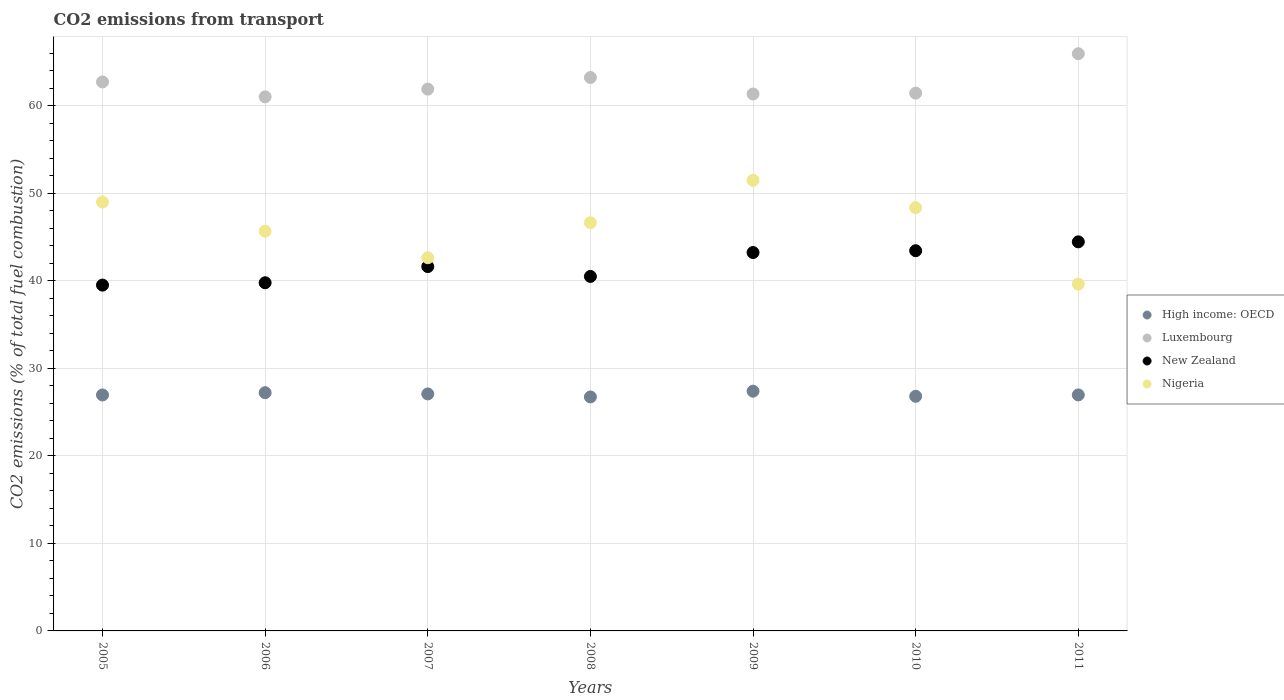Is the number of dotlines equal to the number of legend labels?
Your answer should be very brief. Yes. What is the total CO2 emitted in Nigeria in 2007?
Your answer should be very brief. 42.65. Across all years, what is the maximum total CO2 emitted in High income: OECD?
Your answer should be very brief. 27.4. Across all years, what is the minimum total CO2 emitted in Nigeria?
Offer a very short reply. 39.63. In which year was the total CO2 emitted in Nigeria minimum?
Your answer should be very brief. 2011. What is the total total CO2 emitted in Luxembourg in the graph?
Give a very brief answer. 437.73. What is the difference between the total CO2 emitted in High income: OECD in 2005 and that in 2011?
Your answer should be compact. -0.01. What is the difference between the total CO2 emitted in Nigeria in 2006 and the total CO2 emitted in Luxembourg in 2011?
Offer a very short reply. -20.28. What is the average total CO2 emitted in Luxembourg per year?
Give a very brief answer. 62.53. In the year 2010, what is the difference between the total CO2 emitted in Luxembourg and total CO2 emitted in New Zealand?
Offer a terse response. 18.01. What is the ratio of the total CO2 emitted in High income: OECD in 2007 to that in 2011?
Provide a short and direct response. 1. What is the difference between the highest and the second highest total CO2 emitted in Luxembourg?
Your answer should be very brief. 2.72. What is the difference between the highest and the lowest total CO2 emitted in Nigeria?
Ensure brevity in your answer.  11.86. How many dotlines are there?
Offer a very short reply. 4. How many years are there in the graph?
Provide a succinct answer. 7. What is the difference between two consecutive major ticks on the Y-axis?
Provide a short and direct response. 10. Are the values on the major ticks of Y-axis written in scientific E-notation?
Your answer should be very brief. No. Does the graph contain grids?
Your answer should be very brief. Yes. How many legend labels are there?
Provide a short and direct response. 4. What is the title of the graph?
Give a very brief answer. CO2 emissions from transport. Does "Oman" appear as one of the legend labels in the graph?
Give a very brief answer. No. What is the label or title of the Y-axis?
Provide a short and direct response. CO2 emissions (% of total fuel combustion). What is the CO2 emissions (% of total fuel combustion) in High income: OECD in 2005?
Give a very brief answer. 26.97. What is the CO2 emissions (% of total fuel combustion) of Luxembourg in 2005?
Offer a terse response. 62.74. What is the CO2 emissions (% of total fuel combustion) in New Zealand in 2005?
Provide a succinct answer. 39.52. What is the CO2 emissions (% of total fuel combustion) of Nigeria in 2005?
Your answer should be very brief. 49.01. What is the CO2 emissions (% of total fuel combustion) in High income: OECD in 2006?
Offer a very short reply. 27.23. What is the CO2 emissions (% of total fuel combustion) of Luxembourg in 2006?
Your answer should be very brief. 61.04. What is the CO2 emissions (% of total fuel combustion) of New Zealand in 2006?
Your answer should be very brief. 39.79. What is the CO2 emissions (% of total fuel combustion) of Nigeria in 2006?
Offer a very short reply. 45.68. What is the CO2 emissions (% of total fuel combustion) of High income: OECD in 2007?
Ensure brevity in your answer.  27.08. What is the CO2 emissions (% of total fuel combustion) of Luxembourg in 2007?
Your answer should be compact. 61.92. What is the CO2 emissions (% of total fuel combustion) of New Zealand in 2007?
Offer a terse response. 41.64. What is the CO2 emissions (% of total fuel combustion) of Nigeria in 2007?
Your response must be concise. 42.65. What is the CO2 emissions (% of total fuel combustion) in High income: OECD in 2008?
Your answer should be compact. 26.74. What is the CO2 emissions (% of total fuel combustion) in Luxembourg in 2008?
Your response must be concise. 63.25. What is the CO2 emissions (% of total fuel combustion) of New Zealand in 2008?
Make the answer very short. 40.51. What is the CO2 emissions (% of total fuel combustion) in Nigeria in 2008?
Provide a short and direct response. 46.65. What is the CO2 emissions (% of total fuel combustion) in High income: OECD in 2009?
Your answer should be very brief. 27.4. What is the CO2 emissions (% of total fuel combustion) of Luxembourg in 2009?
Provide a succinct answer. 61.36. What is the CO2 emissions (% of total fuel combustion) of New Zealand in 2009?
Offer a very short reply. 43.25. What is the CO2 emissions (% of total fuel combustion) in Nigeria in 2009?
Provide a succinct answer. 51.49. What is the CO2 emissions (% of total fuel combustion) of High income: OECD in 2010?
Make the answer very short. 26.82. What is the CO2 emissions (% of total fuel combustion) in Luxembourg in 2010?
Provide a short and direct response. 61.46. What is the CO2 emissions (% of total fuel combustion) of New Zealand in 2010?
Make the answer very short. 43.45. What is the CO2 emissions (% of total fuel combustion) of Nigeria in 2010?
Ensure brevity in your answer.  48.37. What is the CO2 emissions (% of total fuel combustion) in High income: OECD in 2011?
Your response must be concise. 26.97. What is the CO2 emissions (% of total fuel combustion) of Luxembourg in 2011?
Your response must be concise. 65.96. What is the CO2 emissions (% of total fuel combustion) of New Zealand in 2011?
Your answer should be very brief. 44.47. What is the CO2 emissions (% of total fuel combustion) of Nigeria in 2011?
Make the answer very short. 39.63. Across all years, what is the maximum CO2 emissions (% of total fuel combustion) in High income: OECD?
Give a very brief answer. 27.4. Across all years, what is the maximum CO2 emissions (% of total fuel combustion) in Luxembourg?
Your answer should be very brief. 65.96. Across all years, what is the maximum CO2 emissions (% of total fuel combustion) in New Zealand?
Your answer should be compact. 44.47. Across all years, what is the maximum CO2 emissions (% of total fuel combustion) of Nigeria?
Make the answer very short. 51.49. Across all years, what is the minimum CO2 emissions (% of total fuel combustion) in High income: OECD?
Your response must be concise. 26.74. Across all years, what is the minimum CO2 emissions (% of total fuel combustion) in Luxembourg?
Make the answer very short. 61.04. Across all years, what is the minimum CO2 emissions (% of total fuel combustion) of New Zealand?
Keep it short and to the point. 39.52. Across all years, what is the minimum CO2 emissions (% of total fuel combustion) of Nigeria?
Your answer should be very brief. 39.63. What is the total CO2 emissions (% of total fuel combustion) of High income: OECD in the graph?
Your response must be concise. 189.21. What is the total CO2 emissions (% of total fuel combustion) in Luxembourg in the graph?
Ensure brevity in your answer.  437.73. What is the total CO2 emissions (% of total fuel combustion) of New Zealand in the graph?
Ensure brevity in your answer.  292.63. What is the total CO2 emissions (% of total fuel combustion) of Nigeria in the graph?
Provide a short and direct response. 323.49. What is the difference between the CO2 emissions (% of total fuel combustion) of High income: OECD in 2005 and that in 2006?
Give a very brief answer. -0.26. What is the difference between the CO2 emissions (% of total fuel combustion) in Luxembourg in 2005 and that in 2006?
Your answer should be compact. 1.71. What is the difference between the CO2 emissions (% of total fuel combustion) of New Zealand in 2005 and that in 2006?
Make the answer very short. -0.27. What is the difference between the CO2 emissions (% of total fuel combustion) in Nigeria in 2005 and that in 2006?
Provide a short and direct response. 3.33. What is the difference between the CO2 emissions (% of total fuel combustion) of High income: OECD in 2005 and that in 2007?
Provide a succinct answer. -0.12. What is the difference between the CO2 emissions (% of total fuel combustion) of Luxembourg in 2005 and that in 2007?
Your answer should be very brief. 0.82. What is the difference between the CO2 emissions (% of total fuel combustion) of New Zealand in 2005 and that in 2007?
Your answer should be very brief. -2.12. What is the difference between the CO2 emissions (% of total fuel combustion) of Nigeria in 2005 and that in 2007?
Your response must be concise. 6.36. What is the difference between the CO2 emissions (% of total fuel combustion) in High income: OECD in 2005 and that in 2008?
Make the answer very short. 0.23. What is the difference between the CO2 emissions (% of total fuel combustion) in Luxembourg in 2005 and that in 2008?
Give a very brief answer. -0.51. What is the difference between the CO2 emissions (% of total fuel combustion) of New Zealand in 2005 and that in 2008?
Provide a succinct answer. -0.99. What is the difference between the CO2 emissions (% of total fuel combustion) of Nigeria in 2005 and that in 2008?
Ensure brevity in your answer.  2.36. What is the difference between the CO2 emissions (% of total fuel combustion) in High income: OECD in 2005 and that in 2009?
Make the answer very short. -0.43. What is the difference between the CO2 emissions (% of total fuel combustion) in Luxembourg in 2005 and that in 2009?
Provide a succinct answer. 1.38. What is the difference between the CO2 emissions (% of total fuel combustion) of New Zealand in 2005 and that in 2009?
Ensure brevity in your answer.  -3.72. What is the difference between the CO2 emissions (% of total fuel combustion) in Nigeria in 2005 and that in 2009?
Your answer should be very brief. -2.48. What is the difference between the CO2 emissions (% of total fuel combustion) of High income: OECD in 2005 and that in 2010?
Offer a very short reply. 0.15. What is the difference between the CO2 emissions (% of total fuel combustion) in Luxembourg in 2005 and that in 2010?
Your response must be concise. 1.28. What is the difference between the CO2 emissions (% of total fuel combustion) of New Zealand in 2005 and that in 2010?
Your response must be concise. -3.93. What is the difference between the CO2 emissions (% of total fuel combustion) of Nigeria in 2005 and that in 2010?
Offer a very short reply. 0.65. What is the difference between the CO2 emissions (% of total fuel combustion) in High income: OECD in 2005 and that in 2011?
Your answer should be compact. -0.01. What is the difference between the CO2 emissions (% of total fuel combustion) in Luxembourg in 2005 and that in 2011?
Provide a short and direct response. -3.22. What is the difference between the CO2 emissions (% of total fuel combustion) of New Zealand in 2005 and that in 2011?
Your answer should be very brief. -4.94. What is the difference between the CO2 emissions (% of total fuel combustion) in Nigeria in 2005 and that in 2011?
Keep it short and to the point. 9.38. What is the difference between the CO2 emissions (% of total fuel combustion) in High income: OECD in 2006 and that in 2007?
Make the answer very short. 0.15. What is the difference between the CO2 emissions (% of total fuel combustion) in Luxembourg in 2006 and that in 2007?
Your answer should be compact. -0.89. What is the difference between the CO2 emissions (% of total fuel combustion) in New Zealand in 2006 and that in 2007?
Your answer should be compact. -1.85. What is the difference between the CO2 emissions (% of total fuel combustion) of Nigeria in 2006 and that in 2007?
Offer a very short reply. 3.03. What is the difference between the CO2 emissions (% of total fuel combustion) in High income: OECD in 2006 and that in 2008?
Provide a succinct answer. 0.49. What is the difference between the CO2 emissions (% of total fuel combustion) of Luxembourg in 2006 and that in 2008?
Provide a short and direct response. -2.21. What is the difference between the CO2 emissions (% of total fuel combustion) of New Zealand in 2006 and that in 2008?
Your answer should be compact. -0.72. What is the difference between the CO2 emissions (% of total fuel combustion) of Nigeria in 2006 and that in 2008?
Make the answer very short. -0.97. What is the difference between the CO2 emissions (% of total fuel combustion) in High income: OECD in 2006 and that in 2009?
Offer a terse response. -0.17. What is the difference between the CO2 emissions (% of total fuel combustion) in Luxembourg in 2006 and that in 2009?
Offer a very short reply. -0.32. What is the difference between the CO2 emissions (% of total fuel combustion) of New Zealand in 2006 and that in 2009?
Your answer should be very brief. -3.46. What is the difference between the CO2 emissions (% of total fuel combustion) in Nigeria in 2006 and that in 2009?
Ensure brevity in your answer.  -5.81. What is the difference between the CO2 emissions (% of total fuel combustion) of High income: OECD in 2006 and that in 2010?
Make the answer very short. 0.41. What is the difference between the CO2 emissions (% of total fuel combustion) of Luxembourg in 2006 and that in 2010?
Ensure brevity in your answer.  -0.42. What is the difference between the CO2 emissions (% of total fuel combustion) of New Zealand in 2006 and that in 2010?
Ensure brevity in your answer.  -3.66. What is the difference between the CO2 emissions (% of total fuel combustion) in Nigeria in 2006 and that in 2010?
Offer a very short reply. -2.69. What is the difference between the CO2 emissions (% of total fuel combustion) in High income: OECD in 2006 and that in 2011?
Provide a succinct answer. 0.26. What is the difference between the CO2 emissions (% of total fuel combustion) of Luxembourg in 2006 and that in 2011?
Provide a succinct answer. -4.93. What is the difference between the CO2 emissions (% of total fuel combustion) of New Zealand in 2006 and that in 2011?
Make the answer very short. -4.68. What is the difference between the CO2 emissions (% of total fuel combustion) in Nigeria in 2006 and that in 2011?
Your answer should be compact. 6.05. What is the difference between the CO2 emissions (% of total fuel combustion) in High income: OECD in 2007 and that in 2008?
Offer a terse response. 0.34. What is the difference between the CO2 emissions (% of total fuel combustion) of Luxembourg in 2007 and that in 2008?
Provide a short and direct response. -1.33. What is the difference between the CO2 emissions (% of total fuel combustion) in New Zealand in 2007 and that in 2008?
Offer a terse response. 1.13. What is the difference between the CO2 emissions (% of total fuel combustion) of Nigeria in 2007 and that in 2008?
Your answer should be compact. -4. What is the difference between the CO2 emissions (% of total fuel combustion) in High income: OECD in 2007 and that in 2009?
Give a very brief answer. -0.32. What is the difference between the CO2 emissions (% of total fuel combustion) in Luxembourg in 2007 and that in 2009?
Offer a terse response. 0.56. What is the difference between the CO2 emissions (% of total fuel combustion) in New Zealand in 2007 and that in 2009?
Provide a succinct answer. -1.61. What is the difference between the CO2 emissions (% of total fuel combustion) of Nigeria in 2007 and that in 2009?
Make the answer very short. -8.84. What is the difference between the CO2 emissions (% of total fuel combustion) of High income: OECD in 2007 and that in 2010?
Keep it short and to the point. 0.27. What is the difference between the CO2 emissions (% of total fuel combustion) of Luxembourg in 2007 and that in 2010?
Offer a very short reply. 0.46. What is the difference between the CO2 emissions (% of total fuel combustion) in New Zealand in 2007 and that in 2010?
Ensure brevity in your answer.  -1.81. What is the difference between the CO2 emissions (% of total fuel combustion) of Nigeria in 2007 and that in 2010?
Your answer should be compact. -5.72. What is the difference between the CO2 emissions (% of total fuel combustion) of High income: OECD in 2007 and that in 2011?
Offer a terse response. 0.11. What is the difference between the CO2 emissions (% of total fuel combustion) of Luxembourg in 2007 and that in 2011?
Your answer should be very brief. -4.04. What is the difference between the CO2 emissions (% of total fuel combustion) of New Zealand in 2007 and that in 2011?
Make the answer very short. -2.83. What is the difference between the CO2 emissions (% of total fuel combustion) in Nigeria in 2007 and that in 2011?
Offer a very short reply. 3.02. What is the difference between the CO2 emissions (% of total fuel combustion) in High income: OECD in 2008 and that in 2009?
Your answer should be compact. -0.66. What is the difference between the CO2 emissions (% of total fuel combustion) in Luxembourg in 2008 and that in 2009?
Provide a short and direct response. 1.89. What is the difference between the CO2 emissions (% of total fuel combustion) in New Zealand in 2008 and that in 2009?
Give a very brief answer. -2.73. What is the difference between the CO2 emissions (% of total fuel combustion) in Nigeria in 2008 and that in 2009?
Make the answer very short. -4.84. What is the difference between the CO2 emissions (% of total fuel combustion) of High income: OECD in 2008 and that in 2010?
Offer a very short reply. -0.08. What is the difference between the CO2 emissions (% of total fuel combustion) of Luxembourg in 2008 and that in 2010?
Give a very brief answer. 1.79. What is the difference between the CO2 emissions (% of total fuel combustion) in New Zealand in 2008 and that in 2010?
Give a very brief answer. -2.94. What is the difference between the CO2 emissions (% of total fuel combustion) in Nigeria in 2008 and that in 2010?
Keep it short and to the point. -1.72. What is the difference between the CO2 emissions (% of total fuel combustion) in High income: OECD in 2008 and that in 2011?
Keep it short and to the point. -0.23. What is the difference between the CO2 emissions (% of total fuel combustion) of Luxembourg in 2008 and that in 2011?
Keep it short and to the point. -2.72. What is the difference between the CO2 emissions (% of total fuel combustion) in New Zealand in 2008 and that in 2011?
Offer a very short reply. -3.95. What is the difference between the CO2 emissions (% of total fuel combustion) of Nigeria in 2008 and that in 2011?
Make the answer very short. 7.02. What is the difference between the CO2 emissions (% of total fuel combustion) in High income: OECD in 2009 and that in 2010?
Ensure brevity in your answer.  0.58. What is the difference between the CO2 emissions (% of total fuel combustion) of Luxembourg in 2009 and that in 2010?
Offer a very short reply. -0.1. What is the difference between the CO2 emissions (% of total fuel combustion) in New Zealand in 2009 and that in 2010?
Offer a terse response. -0.2. What is the difference between the CO2 emissions (% of total fuel combustion) in Nigeria in 2009 and that in 2010?
Give a very brief answer. 3.13. What is the difference between the CO2 emissions (% of total fuel combustion) of High income: OECD in 2009 and that in 2011?
Offer a terse response. 0.43. What is the difference between the CO2 emissions (% of total fuel combustion) in Luxembourg in 2009 and that in 2011?
Your response must be concise. -4.6. What is the difference between the CO2 emissions (% of total fuel combustion) in New Zealand in 2009 and that in 2011?
Keep it short and to the point. -1.22. What is the difference between the CO2 emissions (% of total fuel combustion) in Nigeria in 2009 and that in 2011?
Offer a very short reply. 11.86. What is the difference between the CO2 emissions (% of total fuel combustion) in High income: OECD in 2010 and that in 2011?
Offer a very short reply. -0.16. What is the difference between the CO2 emissions (% of total fuel combustion) of Luxembourg in 2010 and that in 2011?
Provide a succinct answer. -4.51. What is the difference between the CO2 emissions (% of total fuel combustion) of New Zealand in 2010 and that in 2011?
Give a very brief answer. -1.01. What is the difference between the CO2 emissions (% of total fuel combustion) in Nigeria in 2010 and that in 2011?
Your answer should be very brief. 8.74. What is the difference between the CO2 emissions (% of total fuel combustion) in High income: OECD in 2005 and the CO2 emissions (% of total fuel combustion) in Luxembourg in 2006?
Provide a short and direct response. -34.07. What is the difference between the CO2 emissions (% of total fuel combustion) in High income: OECD in 2005 and the CO2 emissions (% of total fuel combustion) in New Zealand in 2006?
Keep it short and to the point. -12.82. What is the difference between the CO2 emissions (% of total fuel combustion) of High income: OECD in 2005 and the CO2 emissions (% of total fuel combustion) of Nigeria in 2006?
Your answer should be compact. -18.71. What is the difference between the CO2 emissions (% of total fuel combustion) of Luxembourg in 2005 and the CO2 emissions (% of total fuel combustion) of New Zealand in 2006?
Make the answer very short. 22.95. What is the difference between the CO2 emissions (% of total fuel combustion) of Luxembourg in 2005 and the CO2 emissions (% of total fuel combustion) of Nigeria in 2006?
Offer a terse response. 17.06. What is the difference between the CO2 emissions (% of total fuel combustion) of New Zealand in 2005 and the CO2 emissions (% of total fuel combustion) of Nigeria in 2006?
Offer a very short reply. -6.16. What is the difference between the CO2 emissions (% of total fuel combustion) of High income: OECD in 2005 and the CO2 emissions (% of total fuel combustion) of Luxembourg in 2007?
Your answer should be compact. -34.96. What is the difference between the CO2 emissions (% of total fuel combustion) in High income: OECD in 2005 and the CO2 emissions (% of total fuel combustion) in New Zealand in 2007?
Provide a short and direct response. -14.67. What is the difference between the CO2 emissions (% of total fuel combustion) in High income: OECD in 2005 and the CO2 emissions (% of total fuel combustion) in Nigeria in 2007?
Make the answer very short. -15.68. What is the difference between the CO2 emissions (% of total fuel combustion) in Luxembourg in 2005 and the CO2 emissions (% of total fuel combustion) in New Zealand in 2007?
Keep it short and to the point. 21.1. What is the difference between the CO2 emissions (% of total fuel combustion) in Luxembourg in 2005 and the CO2 emissions (% of total fuel combustion) in Nigeria in 2007?
Offer a very short reply. 20.09. What is the difference between the CO2 emissions (% of total fuel combustion) of New Zealand in 2005 and the CO2 emissions (% of total fuel combustion) of Nigeria in 2007?
Ensure brevity in your answer.  -3.13. What is the difference between the CO2 emissions (% of total fuel combustion) of High income: OECD in 2005 and the CO2 emissions (% of total fuel combustion) of Luxembourg in 2008?
Provide a succinct answer. -36.28. What is the difference between the CO2 emissions (% of total fuel combustion) in High income: OECD in 2005 and the CO2 emissions (% of total fuel combustion) in New Zealand in 2008?
Provide a succinct answer. -13.55. What is the difference between the CO2 emissions (% of total fuel combustion) in High income: OECD in 2005 and the CO2 emissions (% of total fuel combustion) in Nigeria in 2008?
Your answer should be very brief. -19.69. What is the difference between the CO2 emissions (% of total fuel combustion) in Luxembourg in 2005 and the CO2 emissions (% of total fuel combustion) in New Zealand in 2008?
Make the answer very short. 22.23. What is the difference between the CO2 emissions (% of total fuel combustion) of Luxembourg in 2005 and the CO2 emissions (% of total fuel combustion) of Nigeria in 2008?
Your response must be concise. 16.09. What is the difference between the CO2 emissions (% of total fuel combustion) of New Zealand in 2005 and the CO2 emissions (% of total fuel combustion) of Nigeria in 2008?
Ensure brevity in your answer.  -7.13. What is the difference between the CO2 emissions (% of total fuel combustion) of High income: OECD in 2005 and the CO2 emissions (% of total fuel combustion) of Luxembourg in 2009?
Your response must be concise. -34.39. What is the difference between the CO2 emissions (% of total fuel combustion) in High income: OECD in 2005 and the CO2 emissions (% of total fuel combustion) in New Zealand in 2009?
Your response must be concise. -16.28. What is the difference between the CO2 emissions (% of total fuel combustion) of High income: OECD in 2005 and the CO2 emissions (% of total fuel combustion) of Nigeria in 2009?
Keep it short and to the point. -24.53. What is the difference between the CO2 emissions (% of total fuel combustion) in Luxembourg in 2005 and the CO2 emissions (% of total fuel combustion) in New Zealand in 2009?
Offer a terse response. 19.49. What is the difference between the CO2 emissions (% of total fuel combustion) of Luxembourg in 2005 and the CO2 emissions (% of total fuel combustion) of Nigeria in 2009?
Provide a short and direct response. 11.25. What is the difference between the CO2 emissions (% of total fuel combustion) in New Zealand in 2005 and the CO2 emissions (% of total fuel combustion) in Nigeria in 2009?
Your response must be concise. -11.97. What is the difference between the CO2 emissions (% of total fuel combustion) in High income: OECD in 2005 and the CO2 emissions (% of total fuel combustion) in Luxembourg in 2010?
Offer a very short reply. -34.49. What is the difference between the CO2 emissions (% of total fuel combustion) in High income: OECD in 2005 and the CO2 emissions (% of total fuel combustion) in New Zealand in 2010?
Keep it short and to the point. -16.48. What is the difference between the CO2 emissions (% of total fuel combustion) in High income: OECD in 2005 and the CO2 emissions (% of total fuel combustion) in Nigeria in 2010?
Ensure brevity in your answer.  -21.4. What is the difference between the CO2 emissions (% of total fuel combustion) in Luxembourg in 2005 and the CO2 emissions (% of total fuel combustion) in New Zealand in 2010?
Provide a succinct answer. 19.29. What is the difference between the CO2 emissions (% of total fuel combustion) of Luxembourg in 2005 and the CO2 emissions (% of total fuel combustion) of Nigeria in 2010?
Make the answer very short. 14.37. What is the difference between the CO2 emissions (% of total fuel combustion) in New Zealand in 2005 and the CO2 emissions (% of total fuel combustion) in Nigeria in 2010?
Offer a terse response. -8.85. What is the difference between the CO2 emissions (% of total fuel combustion) in High income: OECD in 2005 and the CO2 emissions (% of total fuel combustion) in Luxembourg in 2011?
Offer a terse response. -39. What is the difference between the CO2 emissions (% of total fuel combustion) in High income: OECD in 2005 and the CO2 emissions (% of total fuel combustion) in New Zealand in 2011?
Your answer should be compact. -17.5. What is the difference between the CO2 emissions (% of total fuel combustion) in High income: OECD in 2005 and the CO2 emissions (% of total fuel combustion) in Nigeria in 2011?
Keep it short and to the point. -12.66. What is the difference between the CO2 emissions (% of total fuel combustion) in Luxembourg in 2005 and the CO2 emissions (% of total fuel combustion) in New Zealand in 2011?
Give a very brief answer. 18.28. What is the difference between the CO2 emissions (% of total fuel combustion) of Luxembourg in 2005 and the CO2 emissions (% of total fuel combustion) of Nigeria in 2011?
Provide a succinct answer. 23.11. What is the difference between the CO2 emissions (% of total fuel combustion) of New Zealand in 2005 and the CO2 emissions (% of total fuel combustion) of Nigeria in 2011?
Offer a very short reply. -0.11. What is the difference between the CO2 emissions (% of total fuel combustion) of High income: OECD in 2006 and the CO2 emissions (% of total fuel combustion) of Luxembourg in 2007?
Your answer should be very brief. -34.69. What is the difference between the CO2 emissions (% of total fuel combustion) in High income: OECD in 2006 and the CO2 emissions (% of total fuel combustion) in New Zealand in 2007?
Your response must be concise. -14.41. What is the difference between the CO2 emissions (% of total fuel combustion) in High income: OECD in 2006 and the CO2 emissions (% of total fuel combustion) in Nigeria in 2007?
Give a very brief answer. -15.42. What is the difference between the CO2 emissions (% of total fuel combustion) of Luxembourg in 2006 and the CO2 emissions (% of total fuel combustion) of New Zealand in 2007?
Your answer should be very brief. 19.4. What is the difference between the CO2 emissions (% of total fuel combustion) in Luxembourg in 2006 and the CO2 emissions (% of total fuel combustion) in Nigeria in 2007?
Provide a short and direct response. 18.39. What is the difference between the CO2 emissions (% of total fuel combustion) of New Zealand in 2006 and the CO2 emissions (% of total fuel combustion) of Nigeria in 2007?
Give a very brief answer. -2.86. What is the difference between the CO2 emissions (% of total fuel combustion) of High income: OECD in 2006 and the CO2 emissions (% of total fuel combustion) of Luxembourg in 2008?
Provide a short and direct response. -36.02. What is the difference between the CO2 emissions (% of total fuel combustion) in High income: OECD in 2006 and the CO2 emissions (% of total fuel combustion) in New Zealand in 2008?
Give a very brief answer. -13.28. What is the difference between the CO2 emissions (% of total fuel combustion) in High income: OECD in 2006 and the CO2 emissions (% of total fuel combustion) in Nigeria in 2008?
Ensure brevity in your answer.  -19.42. What is the difference between the CO2 emissions (% of total fuel combustion) in Luxembourg in 2006 and the CO2 emissions (% of total fuel combustion) in New Zealand in 2008?
Provide a short and direct response. 20.52. What is the difference between the CO2 emissions (% of total fuel combustion) in Luxembourg in 2006 and the CO2 emissions (% of total fuel combustion) in Nigeria in 2008?
Your answer should be very brief. 14.38. What is the difference between the CO2 emissions (% of total fuel combustion) of New Zealand in 2006 and the CO2 emissions (% of total fuel combustion) of Nigeria in 2008?
Your response must be concise. -6.86. What is the difference between the CO2 emissions (% of total fuel combustion) in High income: OECD in 2006 and the CO2 emissions (% of total fuel combustion) in Luxembourg in 2009?
Make the answer very short. -34.13. What is the difference between the CO2 emissions (% of total fuel combustion) in High income: OECD in 2006 and the CO2 emissions (% of total fuel combustion) in New Zealand in 2009?
Make the answer very short. -16.02. What is the difference between the CO2 emissions (% of total fuel combustion) of High income: OECD in 2006 and the CO2 emissions (% of total fuel combustion) of Nigeria in 2009?
Provide a short and direct response. -24.26. What is the difference between the CO2 emissions (% of total fuel combustion) of Luxembourg in 2006 and the CO2 emissions (% of total fuel combustion) of New Zealand in 2009?
Provide a succinct answer. 17.79. What is the difference between the CO2 emissions (% of total fuel combustion) in Luxembourg in 2006 and the CO2 emissions (% of total fuel combustion) in Nigeria in 2009?
Provide a succinct answer. 9.54. What is the difference between the CO2 emissions (% of total fuel combustion) of New Zealand in 2006 and the CO2 emissions (% of total fuel combustion) of Nigeria in 2009?
Offer a very short reply. -11.71. What is the difference between the CO2 emissions (% of total fuel combustion) in High income: OECD in 2006 and the CO2 emissions (% of total fuel combustion) in Luxembourg in 2010?
Offer a terse response. -34.23. What is the difference between the CO2 emissions (% of total fuel combustion) of High income: OECD in 2006 and the CO2 emissions (% of total fuel combustion) of New Zealand in 2010?
Give a very brief answer. -16.22. What is the difference between the CO2 emissions (% of total fuel combustion) of High income: OECD in 2006 and the CO2 emissions (% of total fuel combustion) of Nigeria in 2010?
Your answer should be very brief. -21.14. What is the difference between the CO2 emissions (% of total fuel combustion) of Luxembourg in 2006 and the CO2 emissions (% of total fuel combustion) of New Zealand in 2010?
Your answer should be very brief. 17.59. What is the difference between the CO2 emissions (% of total fuel combustion) of Luxembourg in 2006 and the CO2 emissions (% of total fuel combustion) of Nigeria in 2010?
Your answer should be compact. 12.67. What is the difference between the CO2 emissions (% of total fuel combustion) in New Zealand in 2006 and the CO2 emissions (% of total fuel combustion) in Nigeria in 2010?
Make the answer very short. -8.58. What is the difference between the CO2 emissions (% of total fuel combustion) in High income: OECD in 2006 and the CO2 emissions (% of total fuel combustion) in Luxembourg in 2011?
Your response must be concise. -38.73. What is the difference between the CO2 emissions (% of total fuel combustion) of High income: OECD in 2006 and the CO2 emissions (% of total fuel combustion) of New Zealand in 2011?
Make the answer very short. -17.24. What is the difference between the CO2 emissions (% of total fuel combustion) of High income: OECD in 2006 and the CO2 emissions (% of total fuel combustion) of Nigeria in 2011?
Offer a terse response. -12.4. What is the difference between the CO2 emissions (% of total fuel combustion) of Luxembourg in 2006 and the CO2 emissions (% of total fuel combustion) of New Zealand in 2011?
Offer a terse response. 16.57. What is the difference between the CO2 emissions (% of total fuel combustion) of Luxembourg in 2006 and the CO2 emissions (% of total fuel combustion) of Nigeria in 2011?
Provide a short and direct response. 21.41. What is the difference between the CO2 emissions (% of total fuel combustion) of New Zealand in 2006 and the CO2 emissions (% of total fuel combustion) of Nigeria in 2011?
Give a very brief answer. 0.16. What is the difference between the CO2 emissions (% of total fuel combustion) in High income: OECD in 2007 and the CO2 emissions (% of total fuel combustion) in Luxembourg in 2008?
Make the answer very short. -36.16. What is the difference between the CO2 emissions (% of total fuel combustion) of High income: OECD in 2007 and the CO2 emissions (% of total fuel combustion) of New Zealand in 2008?
Offer a very short reply. -13.43. What is the difference between the CO2 emissions (% of total fuel combustion) in High income: OECD in 2007 and the CO2 emissions (% of total fuel combustion) in Nigeria in 2008?
Your answer should be compact. -19.57. What is the difference between the CO2 emissions (% of total fuel combustion) in Luxembourg in 2007 and the CO2 emissions (% of total fuel combustion) in New Zealand in 2008?
Provide a short and direct response. 21.41. What is the difference between the CO2 emissions (% of total fuel combustion) of Luxembourg in 2007 and the CO2 emissions (% of total fuel combustion) of Nigeria in 2008?
Your answer should be compact. 15.27. What is the difference between the CO2 emissions (% of total fuel combustion) of New Zealand in 2007 and the CO2 emissions (% of total fuel combustion) of Nigeria in 2008?
Your answer should be compact. -5.01. What is the difference between the CO2 emissions (% of total fuel combustion) in High income: OECD in 2007 and the CO2 emissions (% of total fuel combustion) in Luxembourg in 2009?
Keep it short and to the point. -34.28. What is the difference between the CO2 emissions (% of total fuel combustion) of High income: OECD in 2007 and the CO2 emissions (% of total fuel combustion) of New Zealand in 2009?
Your response must be concise. -16.16. What is the difference between the CO2 emissions (% of total fuel combustion) of High income: OECD in 2007 and the CO2 emissions (% of total fuel combustion) of Nigeria in 2009?
Your response must be concise. -24.41. What is the difference between the CO2 emissions (% of total fuel combustion) of Luxembourg in 2007 and the CO2 emissions (% of total fuel combustion) of New Zealand in 2009?
Offer a terse response. 18.68. What is the difference between the CO2 emissions (% of total fuel combustion) in Luxembourg in 2007 and the CO2 emissions (% of total fuel combustion) in Nigeria in 2009?
Provide a succinct answer. 10.43. What is the difference between the CO2 emissions (% of total fuel combustion) of New Zealand in 2007 and the CO2 emissions (% of total fuel combustion) of Nigeria in 2009?
Offer a terse response. -9.85. What is the difference between the CO2 emissions (% of total fuel combustion) of High income: OECD in 2007 and the CO2 emissions (% of total fuel combustion) of Luxembourg in 2010?
Your answer should be compact. -34.37. What is the difference between the CO2 emissions (% of total fuel combustion) in High income: OECD in 2007 and the CO2 emissions (% of total fuel combustion) in New Zealand in 2010?
Your response must be concise. -16.37. What is the difference between the CO2 emissions (% of total fuel combustion) of High income: OECD in 2007 and the CO2 emissions (% of total fuel combustion) of Nigeria in 2010?
Your answer should be very brief. -21.28. What is the difference between the CO2 emissions (% of total fuel combustion) in Luxembourg in 2007 and the CO2 emissions (% of total fuel combustion) in New Zealand in 2010?
Offer a very short reply. 18.47. What is the difference between the CO2 emissions (% of total fuel combustion) in Luxembourg in 2007 and the CO2 emissions (% of total fuel combustion) in Nigeria in 2010?
Ensure brevity in your answer.  13.55. What is the difference between the CO2 emissions (% of total fuel combustion) of New Zealand in 2007 and the CO2 emissions (% of total fuel combustion) of Nigeria in 2010?
Ensure brevity in your answer.  -6.73. What is the difference between the CO2 emissions (% of total fuel combustion) in High income: OECD in 2007 and the CO2 emissions (% of total fuel combustion) in Luxembourg in 2011?
Your answer should be compact. -38.88. What is the difference between the CO2 emissions (% of total fuel combustion) in High income: OECD in 2007 and the CO2 emissions (% of total fuel combustion) in New Zealand in 2011?
Your answer should be very brief. -17.38. What is the difference between the CO2 emissions (% of total fuel combustion) of High income: OECD in 2007 and the CO2 emissions (% of total fuel combustion) of Nigeria in 2011?
Keep it short and to the point. -12.55. What is the difference between the CO2 emissions (% of total fuel combustion) in Luxembourg in 2007 and the CO2 emissions (% of total fuel combustion) in New Zealand in 2011?
Your answer should be compact. 17.46. What is the difference between the CO2 emissions (% of total fuel combustion) in Luxembourg in 2007 and the CO2 emissions (% of total fuel combustion) in Nigeria in 2011?
Keep it short and to the point. 22.29. What is the difference between the CO2 emissions (% of total fuel combustion) in New Zealand in 2007 and the CO2 emissions (% of total fuel combustion) in Nigeria in 2011?
Ensure brevity in your answer.  2.01. What is the difference between the CO2 emissions (% of total fuel combustion) in High income: OECD in 2008 and the CO2 emissions (% of total fuel combustion) in Luxembourg in 2009?
Give a very brief answer. -34.62. What is the difference between the CO2 emissions (% of total fuel combustion) in High income: OECD in 2008 and the CO2 emissions (% of total fuel combustion) in New Zealand in 2009?
Offer a terse response. -16.51. What is the difference between the CO2 emissions (% of total fuel combustion) of High income: OECD in 2008 and the CO2 emissions (% of total fuel combustion) of Nigeria in 2009?
Your answer should be very brief. -24.75. What is the difference between the CO2 emissions (% of total fuel combustion) in Luxembourg in 2008 and the CO2 emissions (% of total fuel combustion) in New Zealand in 2009?
Your answer should be very brief. 20. What is the difference between the CO2 emissions (% of total fuel combustion) of Luxembourg in 2008 and the CO2 emissions (% of total fuel combustion) of Nigeria in 2009?
Your answer should be very brief. 11.75. What is the difference between the CO2 emissions (% of total fuel combustion) of New Zealand in 2008 and the CO2 emissions (% of total fuel combustion) of Nigeria in 2009?
Keep it short and to the point. -10.98. What is the difference between the CO2 emissions (% of total fuel combustion) of High income: OECD in 2008 and the CO2 emissions (% of total fuel combustion) of Luxembourg in 2010?
Your answer should be very brief. -34.72. What is the difference between the CO2 emissions (% of total fuel combustion) in High income: OECD in 2008 and the CO2 emissions (% of total fuel combustion) in New Zealand in 2010?
Give a very brief answer. -16.71. What is the difference between the CO2 emissions (% of total fuel combustion) in High income: OECD in 2008 and the CO2 emissions (% of total fuel combustion) in Nigeria in 2010?
Your answer should be very brief. -21.63. What is the difference between the CO2 emissions (% of total fuel combustion) of Luxembourg in 2008 and the CO2 emissions (% of total fuel combustion) of New Zealand in 2010?
Offer a terse response. 19.8. What is the difference between the CO2 emissions (% of total fuel combustion) of Luxembourg in 2008 and the CO2 emissions (% of total fuel combustion) of Nigeria in 2010?
Ensure brevity in your answer.  14.88. What is the difference between the CO2 emissions (% of total fuel combustion) in New Zealand in 2008 and the CO2 emissions (% of total fuel combustion) in Nigeria in 2010?
Provide a succinct answer. -7.86. What is the difference between the CO2 emissions (% of total fuel combustion) in High income: OECD in 2008 and the CO2 emissions (% of total fuel combustion) in Luxembourg in 2011?
Give a very brief answer. -39.22. What is the difference between the CO2 emissions (% of total fuel combustion) of High income: OECD in 2008 and the CO2 emissions (% of total fuel combustion) of New Zealand in 2011?
Make the answer very short. -17.73. What is the difference between the CO2 emissions (% of total fuel combustion) of High income: OECD in 2008 and the CO2 emissions (% of total fuel combustion) of Nigeria in 2011?
Offer a terse response. -12.89. What is the difference between the CO2 emissions (% of total fuel combustion) in Luxembourg in 2008 and the CO2 emissions (% of total fuel combustion) in New Zealand in 2011?
Your answer should be very brief. 18.78. What is the difference between the CO2 emissions (% of total fuel combustion) in Luxembourg in 2008 and the CO2 emissions (% of total fuel combustion) in Nigeria in 2011?
Keep it short and to the point. 23.62. What is the difference between the CO2 emissions (% of total fuel combustion) of New Zealand in 2008 and the CO2 emissions (% of total fuel combustion) of Nigeria in 2011?
Your answer should be compact. 0.88. What is the difference between the CO2 emissions (% of total fuel combustion) of High income: OECD in 2009 and the CO2 emissions (% of total fuel combustion) of Luxembourg in 2010?
Your answer should be compact. -34.06. What is the difference between the CO2 emissions (% of total fuel combustion) in High income: OECD in 2009 and the CO2 emissions (% of total fuel combustion) in New Zealand in 2010?
Provide a succinct answer. -16.05. What is the difference between the CO2 emissions (% of total fuel combustion) in High income: OECD in 2009 and the CO2 emissions (% of total fuel combustion) in Nigeria in 2010?
Provide a succinct answer. -20.97. What is the difference between the CO2 emissions (% of total fuel combustion) in Luxembourg in 2009 and the CO2 emissions (% of total fuel combustion) in New Zealand in 2010?
Provide a short and direct response. 17.91. What is the difference between the CO2 emissions (% of total fuel combustion) of Luxembourg in 2009 and the CO2 emissions (% of total fuel combustion) of Nigeria in 2010?
Keep it short and to the point. 12.99. What is the difference between the CO2 emissions (% of total fuel combustion) of New Zealand in 2009 and the CO2 emissions (% of total fuel combustion) of Nigeria in 2010?
Your response must be concise. -5.12. What is the difference between the CO2 emissions (% of total fuel combustion) of High income: OECD in 2009 and the CO2 emissions (% of total fuel combustion) of Luxembourg in 2011?
Give a very brief answer. -38.56. What is the difference between the CO2 emissions (% of total fuel combustion) of High income: OECD in 2009 and the CO2 emissions (% of total fuel combustion) of New Zealand in 2011?
Provide a succinct answer. -17.07. What is the difference between the CO2 emissions (% of total fuel combustion) in High income: OECD in 2009 and the CO2 emissions (% of total fuel combustion) in Nigeria in 2011?
Provide a succinct answer. -12.23. What is the difference between the CO2 emissions (% of total fuel combustion) of Luxembourg in 2009 and the CO2 emissions (% of total fuel combustion) of New Zealand in 2011?
Your answer should be very brief. 16.89. What is the difference between the CO2 emissions (% of total fuel combustion) of Luxembourg in 2009 and the CO2 emissions (% of total fuel combustion) of Nigeria in 2011?
Your answer should be compact. 21.73. What is the difference between the CO2 emissions (% of total fuel combustion) in New Zealand in 2009 and the CO2 emissions (% of total fuel combustion) in Nigeria in 2011?
Offer a terse response. 3.62. What is the difference between the CO2 emissions (% of total fuel combustion) of High income: OECD in 2010 and the CO2 emissions (% of total fuel combustion) of Luxembourg in 2011?
Your answer should be very brief. -39.15. What is the difference between the CO2 emissions (% of total fuel combustion) of High income: OECD in 2010 and the CO2 emissions (% of total fuel combustion) of New Zealand in 2011?
Your answer should be compact. -17.65. What is the difference between the CO2 emissions (% of total fuel combustion) of High income: OECD in 2010 and the CO2 emissions (% of total fuel combustion) of Nigeria in 2011?
Your response must be concise. -12.81. What is the difference between the CO2 emissions (% of total fuel combustion) in Luxembourg in 2010 and the CO2 emissions (% of total fuel combustion) in New Zealand in 2011?
Offer a very short reply. 16.99. What is the difference between the CO2 emissions (% of total fuel combustion) in Luxembourg in 2010 and the CO2 emissions (% of total fuel combustion) in Nigeria in 2011?
Keep it short and to the point. 21.83. What is the difference between the CO2 emissions (% of total fuel combustion) in New Zealand in 2010 and the CO2 emissions (% of total fuel combustion) in Nigeria in 2011?
Give a very brief answer. 3.82. What is the average CO2 emissions (% of total fuel combustion) in High income: OECD per year?
Offer a terse response. 27.03. What is the average CO2 emissions (% of total fuel combustion) of Luxembourg per year?
Offer a very short reply. 62.53. What is the average CO2 emissions (% of total fuel combustion) of New Zealand per year?
Make the answer very short. 41.8. What is the average CO2 emissions (% of total fuel combustion) of Nigeria per year?
Offer a terse response. 46.21. In the year 2005, what is the difference between the CO2 emissions (% of total fuel combustion) in High income: OECD and CO2 emissions (% of total fuel combustion) in Luxembourg?
Offer a terse response. -35.77. In the year 2005, what is the difference between the CO2 emissions (% of total fuel combustion) of High income: OECD and CO2 emissions (% of total fuel combustion) of New Zealand?
Make the answer very short. -12.55. In the year 2005, what is the difference between the CO2 emissions (% of total fuel combustion) of High income: OECD and CO2 emissions (% of total fuel combustion) of Nigeria?
Make the answer very short. -22.05. In the year 2005, what is the difference between the CO2 emissions (% of total fuel combustion) of Luxembourg and CO2 emissions (% of total fuel combustion) of New Zealand?
Offer a very short reply. 23.22. In the year 2005, what is the difference between the CO2 emissions (% of total fuel combustion) in Luxembourg and CO2 emissions (% of total fuel combustion) in Nigeria?
Make the answer very short. 13.73. In the year 2005, what is the difference between the CO2 emissions (% of total fuel combustion) in New Zealand and CO2 emissions (% of total fuel combustion) in Nigeria?
Make the answer very short. -9.49. In the year 2006, what is the difference between the CO2 emissions (% of total fuel combustion) in High income: OECD and CO2 emissions (% of total fuel combustion) in Luxembourg?
Keep it short and to the point. -33.81. In the year 2006, what is the difference between the CO2 emissions (% of total fuel combustion) of High income: OECD and CO2 emissions (% of total fuel combustion) of New Zealand?
Your answer should be compact. -12.56. In the year 2006, what is the difference between the CO2 emissions (% of total fuel combustion) in High income: OECD and CO2 emissions (% of total fuel combustion) in Nigeria?
Provide a short and direct response. -18.45. In the year 2006, what is the difference between the CO2 emissions (% of total fuel combustion) in Luxembourg and CO2 emissions (% of total fuel combustion) in New Zealand?
Your answer should be very brief. 21.25. In the year 2006, what is the difference between the CO2 emissions (% of total fuel combustion) in Luxembourg and CO2 emissions (% of total fuel combustion) in Nigeria?
Offer a terse response. 15.36. In the year 2006, what is the difference between the CO2 emissions (% of total fuel combustion) in New Zealand and CO2 emissions (% of total fuel combustion) in Nigeria?
Give a very brief answer. -5.89. In the year 2007, what is the difference between the CO2 emissions (% of total fuel combustion) of High income: OECD and CO2 emissions (% of total fuel combustion) of Luxembourg?
Give a very brief answer. -34.84. In the year 2007, what is the difference between the CO2 emissions (% of total fuel combustion) in High income: OECD and CO2 emissions (% of total fuel combustion) in New Zealand?
Provide a short and direct response. -14.56. In the year 2007, what is the difference between the CO2 emissions (% of total fuel combustion) in High income: OECD and CO2 emissions (% of total fuel combustion) in Nigeria?
Make the answer very short. -15.57. In the year 2007, what is the difference between the CO2 emissions (% of total fuel combustion) of Luxembourg and CO2 emissions (% of total fuel combustion) of New Zealand?
Your answer should be very brief. 20.28. In the year 2007, what is the difference between the CO2 emissions (% of total fuel combustion) of Luxembourg and CO2 emissions (% of total fuel combustion) of Nigeria?
Give a very brief answer. 19.27. In the year 2007, what is the difference between the CO2 emissions (% of total fuel combustion) of New Zealand and CO2 emissions (% of total fuel combustion) of Nigeria?
Provide a short and direct response. -1.01. In the year 2008, what is the difference between the CO2 emissions (% of total fuel combustion) of High income: OECD and CO2 emissions (% of total fuel combustion) of Luxembourg?
Keep it short and to the point. -36.51. In the year 2008, what is the difference between the CO2 emissions (% of total fuel combustion) in High income: OECD and CO2 emissions (% of total fuel combustion) in New Zealand?
Offer a very short reply. -13.77. In the year 2008, what is the difference between the CO2 emissions (% of total fuel combustion) of High income: OECD and CO2 emissions (% of total fuel combustion) of Nigeria?
Keep it short and to the point. -19.91. In the year 2008, what is the difference between the CO2 emissions (% of total fuel combustion) in Luxembourg and CO2 emissions (% of total fuel combustion) in New Zealand?
Keep it short and to the point. 22.74. In the year 2008, what is the difference between the CO2 emissions (% of total fuel combustion) in Luxembourg and CO2 emissions (% of total fuel combustion) in Nigeria?
Offer a very short reply. 16.59. In the year 2008, what is the difference between the CO2 emissions (% of total fuel combustion) of New Zealand and CO2 emissions (% of total fuel combustion) of Nigeria?
Give a very brief answer. -6.14. In the year 2009, what is the difference between the CO2 emissions (% of total fuel combustion) of High income: OECD and CO2 emissions (% of total fuel combustion) of Luxembourg?
Give a very brief answer. -33.96. In the year 2009, what is the difference between the CO2 emissions (% of total fuel combustion) in High income: OECD and CO2 emissions (% of total fuel combustion) in New Zealand?
Give a very brief answer. -15.85. In the year 2009, what is the difference between the CO2 emissions (% of total fuel combustion) of High income: OECD and CO2 emissions (% of total fuel combustion) of Nigeria?
Provide a short and direct response. -24.09. In the year 2009, what is the difference between the CO2 emissions (% of total fuel combustion) of Luxembourg and CO2 emissions (% of total fuel combustion) of New Zealand?
Provide a succinct answer. 18.11. In the year 2009, what is the difference between the CO2 emissions (% of total fuel combustion) of Luxembourg and CO2 emissions (% of total fuel combustion) of Nigeria?
Your answer should be compact. 9.87. In the year 2009, what is the difference between the CO2 emissions (% of total fuel combustion) of New Zealand and CO2 emissions (% of total fuel combustion) of Nigeria?
Provide a succinct answer. -8.25. In the year 2010, what is the difference between the CO2 emissions (% of total fuel combustion) of High income: OECD and CO2 emissions (% of total fuel combustion) of Luxembourg?
Your response must be concise. -34.64. In the year 2010, what is the difference between the CO2 emissions (% of total fuel combustion) in High income: OECD and CO2 emissions (% of total fuel combustion) in New Zealand?
Your answer should be very brief. -16.64. In the year 2010, what is the difference between the CO2 emissions (% of total fuel combustion) in High income: OECD and CO2 emissions (% of total fuel combustion) in Nigeria?
Offer a terse response. -21.55. In the year 2010, what is the difference between the CO2 emissions (% of total fuel combustion) of Luxembourg and CO2 emissions (% of total fuel combustion) of New Zealand?
Your answer should be very brief. 18.01. In the year 2010, what is the difference between the CO2 emissions (% of total fuel combustion) in Luxembourg and CO2 emissions (% of total fuel combustion) in Nigeria?
Offer a terse response. 13.09. In the year 2010, what is the difference between the CO2 emissions (% of total fuel combustion) of New Zealand and CO2 emissions (% of total fuel combustion) of Nigeria?
Keep it short and to the point. -4.92. In the year 2011, what is the difference between the CO2 emissions (% of total fuel combustion) in High income: OECD and CO2 emissions (% of total fuel combustion) in Luxembourg?
Provide a succinct answer. -38.99. In the year 2011, what is the difference between the CO2 emissions (% of total fuel combustion) of High income: OECD and CO2 emissions (% of total fuel combustion) of New Zealand?
Ensure brevity in your answer.  -17.49. In the year 2011, what is the difference between the CO2 emissions (% of total fuel combustion) in High income: OECD and CO2 emissions (% of total fuel combustion) in Nigeria?
Make the answer very short. -12.66. In the year 2011, what is the difference between the CO2 emissions (% of total fuel combustion) of Luxembourg and CO2 emissions (% of total fuel combustion) of New Zealand?
Your answer should be very brief. 21.5. In the year 2011, what is the difference between the CO2 emissions (% of total fuel combustion) in Luxembourg and CO2 emissions (% of total fuel combustion) in Nigeria?
Offer a terse response. 26.33. In the year 2011, what is the difference between the CO2 emissions (% of total fuel combustion) in New Zealand and CO2 emissions (% of total fuel combustion) in Nigeria?
Give a very brief answer. 4.84. What is the ratio of the CO2 emissions (% of total fuel combustion) of Luxembourg in 2005 to that in 2006?
Ensure brevity in your answer.  1.03. What is the ratio of the CO2 emissions (% of total fuel combustion) of New Zealand in 2005 to that in 2006?
Offer a very short reply. 0.99. What is the ratio of the CO2 emissions (% of total fuel combustion) of Nigeria in 2005 to that in 2006?
Make the answer very short. 1.07. What is the ratio of the CO2 emissions (% of total fuel combustion) in High income: OECD in 2005 to that in 2007?
Provide a short and direct response. 1. What is the ratio of the CO2 emissions (% of total fuel combustion) in Luxembourg in 2005 to that in 2007?
Ensure brevity in your answer.  1.01. What is the ratio of the CO2 emissions (% of total fuel combustion) of New Zealand in 2005 to that in 2007?
Make the answer very short. 0.95. What is the ratio of the CO2 emissions (% of total fuel combustion) in Nigeria in 2005 to that in 2007?
Give a very brief answer. 1.15. What is the ratio of the CO2 emissions (% of total fuel combustion) in High income: OECD in 2005 to that in 2008?
Provide a succinct answer. 1.01. What is the ratio of the CO2 emissions (% of total fuel combustion) in New Zealand in 2005 to that in 2008?
Your answer should be compact. 0.98. What is the ratio of the CO2 emissions (% of total fuel combustion) in Nigeria in 2005 to that in 2008?
Provide a succinct answer. 1.05. What is the ratio of the CO2 emissions (% of total fuel combustion) in High income: OECD in 2005 to that in 2009?
Your answer should be very brief. 0.98. What is the ratio of the CO2 emissions (% of total fuel combustion) in Luxembourg in 2005 to that in 2009?
Offer a terse response. 1.02. What is the ratio of the CO2 emissions (% of total fuel combustion) of New Zealand in 2005 to that in 2009?
Offer a very short reply. 0.91. What is the ratio of the CO2 emissions (% of total fuel combustion) in Nigeria in 2005 to that in 2009?
Offer a terse response. 0.95. What is the ratio of the CO2 emissions (% of total fuel combustion) in High income: OECD in 2005 to that in 2010?
Provide a short and direct response. 1.01. What is the ratio of the CO2 emissions (% of total fuel combustion) of Luxembourg in 2005 to that in 2010?
Provide a short and direct response. 1.02. What is the ratio of the CO2 emissions (% of total fuel combustion) of New Zealand in 2005 to that in 2010?
Your response must be concise. 0.91. What is the ratio of the CO2 emissions (% of total fuel combustion) of Nigeria in 2005 to that in 2010?
Give a very brief answer. 1.01. What is the ratio of the CO2 emissions (% of total fuel combustion) in High income: OECD in 2005 to that in 2011?
Make the answer very short. 1. What is the ratio of the CO2 emissions (% of total fuel combustion) in Luxembourg in 2005 to that in 2011?
Give a very brief answer. 0.95. What is the ratio of the CO2 emissions (% of total fuel combustion) of New Zealand in 2005 to that in 2011?
Your response must be concise. 0.89. What is the ratio of the CO2 emissions (% of total fuel combustion) in Nigeria in 2005 to that in 2011?
Provide a succinct answer. 1.24. What is the ratio of the CO2 emissions (% of total fuel combustion) of High income: OECD in 2006 to that in 2007?
Provide a short and direct response. 1.01. What is the ratio of the CO2 emissions (% of total fuel combustion) of Luxembourg in 2006 to that in 2007?
Your response must be concise. 0.99. What is the ratio of the CO2 emissions (% of total fuel combustion) in New Zealand in 2006 to that in 2007?
Your answer should be compact. 0.96. What is the ratio of the CO2 emissions (% of total fuel combustion) of Nigeria in 2006 to that in 2007?
Keep it short and to the point. 1.07. What is the ratio of the CO2 emissions (% of total fuel combustion) in High income: OECD in 2006 to that in 2008?
Provide a succinct answer. 1.02. What is the ratio of the CO2 emissions (% of total fuel combustion) in New Zealand in 2006 to that in 2008?
Offer a terse response. 0.98. What is the ratio of the CO2 emissions (% of total fuel combustion) of Nigeria in 2006 to that in 2008?
Ensure brevity in your answer.  0.98. What is the ratio of the CO2 emissions (% of total fuel combustion) in Luxembourg in 2006 to that in 2009?
Your response must be concise. 0.99. What is the ratio of the CO2 emissions (% of total fuel combustion) in Nigeria in 2006 to that in 2009?
Offer a very short reply. 0.89. What is the ratio of the CO2 emissions (% of total fuel combustion) of High income: OECD in 2006 to that in 2010?
Your answer should be very brief. 1.02. What is the ratio of the CO2 emissions (% of total fuel combustion) in Luxembourg in 2006 to that in 2010?
Provide a short and direct response. 0.99. What is the ratio of the CO2 emissions (% of total fuel combustion) of New Zealand in 2006 to that in 2010?
Your answer should be very brief. 0.92. What is the ratio of the CO2 emissions (% of total fuel combustion) in Nigeria in 2006 to that in 2010?
Make the answer very short. 0.94. What is the ratio of the CO2 emissions (% of total fuel combustion) in High income: OECD in 2006 to that in 2011?
Provide a succinct answer. 1.01. What is the ratio of the CO2 emissions (% of total fuel combustion) of Luxembourg in 2006 to that in 2011?
Your answer should be very brief. 0.93. What is the ratio of the CO2 emissions (% of total fuel combustion) in New Zealand in 2006 to that in 2011?
Keep it short and to the point. 0.89. What is the ratio of the CO2 emissions (% of total fuel combustion) of Nigeria in 2006 to that in 2011?
Your response must be concise. 1.15. What is the ratio of the CO2 emissions (% of total fuel combustion) of High income: OECD in 2007 to that in 2008?
Make the answer very short. 1.01. What is the ratio of the CO2 emissions (% of total fuel combustion) of Luxembourg in 2007 to that in 2008?
Provide a succinct answer. 0.98. What is the ratio of the CO2 emissions (% of total fuel combustion) in New Zealand in 2007 to that in 2008?
Offer a very short reply. 1.03. What is the ratio of the CO2 emissions (% of total fuel combustion) of Nigeria in 2007 to that in 2008?
Provide a succinct answer. 0.91. What is the ratio of the CO2 emissions (% of total fuel combustion) in Luxembourg in 2007 to that in 2009?
Make the answer very short. 1.01. What is the ratio of the CO2 emissions (% of total fuel combustion) in New Zealand in 2007 to that in 2009?
Offer a very short reply. 0.96. What is the ratio of the CO2 emissions (% of total fuel combustion) of Nigeria in 2007 to that in 2009?
Make the answer very short. 0.83. What is the ratio of the CO2 emissions (% of total fuel combustion) in Luxembourg in 2007 to that in 2010?
Offer a terse response. 1.01. What is the ratio of the CO2 emissions (% of total fuel combustion) in New Zealand in 2007 to that in 2010?
Offer a terse response. 0.96. What is the ratio of the CO2 emissions (% of total fuel combustion) in Nigeria in 2007 to that in 2010?
Your answer should be compact. 0.88. What is the ratio of the CO2 emissions (% of total fuel combustion) of Luxembourg in 2007 to that in 2011?
Make the answer very short. 0.94. What is the ratio of the CO2 emissions (% of total fuel combustion) in New Zealand in 2007 to that in 2011?
Provide a succinct answer. 0.94. What is the ratio of the CO2 emissions (% of total fuel combustion) of Nigeria in 2007 to that in 2011?
Your response must be concise. 1.08. What is the ratio of the CO2 emissions (% of total fuel combustion) of High income: OECD in 2008 to that in 2009?
Offer a very short reply. 0.98. What is the ratio of the CO2 emissions (% of total fuel combustion) of Luxembourg in 2008 to that in 2009?
Offer a terse response. 1.03. What is the ratio of the CO2 emissions (% of total fuel combustion) of New Zealand in 2008 to that in 2009?
Offer a terse response. 0.94. What is the ratio of the CO2 emissions (% of total fuel combustion) in Nigeria in 2008 to that in 2009?
Offer a very short reply. 0.91. What is the ratio of the CO2 emissions (% of total fuel combustion) of Luxembourg in 2008 to that in 2010?
Offer a terse response. 1.03. What is the ratio of the CO2 emissions (% of total fuel combustion) of New Zealand in 2008 to that in 2010?
Your answer should be compact. 0.93. What is the ratio of the CO2 emissions (% of total fuel combustion) of Nigeria in 2008 to that in 2010?
Give a very brief answer. 0.96. What is the ratio of the CO2 emissions (% of total fuel combustion) of Luxembourg in 2008 to that in 2011?
Your answer should be very brief. 0.96. What is the ratio of the CO2 emissions (% of total fuel combustion) in New Zealand in 2008 to that in 2011?
Keep it short and to the point. 0.91. What is the ratio of the CO2 emissions (% of total fuel combustion) of Nigeria in 2008 to that in 2011?
Make the answer very short. 1.18. What is the ratio of the CO2 emissions (% of total fuel combustion) of High income: OECD in 2009 to that in 2010?
Give a very brief answer. 1.02. What is the ratio of the CO2 emissions (% of total fuel combustion) of New Zealand in 2009 to that in 2010?
Ensure brevity in your answer.  1. What is the ratio of the CO2 emissions (% of total fuel combustion) in Nigeria in 2009 to that in 2010?
Your answer should be very brief. 1.06. What is the ratio of the CO2 emissions (% of total fuel combustion) of High income: OECD in 2009 to that in 2011?
Your answer should be compact. 1.02. What is the ratio of the CO2 emissions (% of total fuel combustion) of Luxembourg in 2009 to that in 2011?
Your answer should be very brief. 0.93. What is the ratio of the CO2 emissions (% of total fuel combustion) of New Zealand in 2009 to that in 2011?
Your response must be concise. 0.97. What is the ratio of the CO2 emissions (% of total fuel combustion) of Nigeria in 2009 to that in 2011?
Your answer should be very brief. 1.3. What is the ratio of the CO2 emissions (% of total fuel combustion) in Luxembourg in 2010 to that in 2011?
Your response must be concise. 0.93. What is the ratio of the CO2 emissions (% of total fuel combustion) of New Zealand in 2010 to that in 2011?
Make the answer very short. 0.98. What is the ratio of the CO2 emissions (% of total fuel combustion) of Nigeria in 2010 to that in 2011?
Keep it short and to the point. 1.22. What is the difference between the highest and the second highest CO2 emissions (% of total fuel combustion) of High income: OECD?
Your answer should be very brief. 0.17. What is the difference between the highest and the second highest CO2 emissions (% of total fuel combustion) of Luxembourg?
Ensure brevity in your answer.  2.72. What is the difference between the highest and the second highest CO2 emissions (% of total fuel combustion) of New Zealand?
Keep it short and to the point. 1.01. What is the difference between the highest and the second highest CO2 emissions (% of total fuel combustion) in Nigeria?
Your response must be concise. 2.48. What is the difference between the highest and the lowest CO2 emissions (% of total fuel combustion) in High income: OECD?
Offer a very short reply. 0.66. What is the difference between the highest and the lowest CO2 emissions (% of total fuel combustion) in Luxembourg?
Give a very brief answer. 4.93. What is the difference between the highest and the lowest CO2 emissions (% of total fuel combustion) of New Zealand?
Your answer should be compact. 4.94. What is the difference between the highest and the lowest CO2 emissions (% of total fuel combustion) of Nigeria?
Your response must be concise. 11.86. 